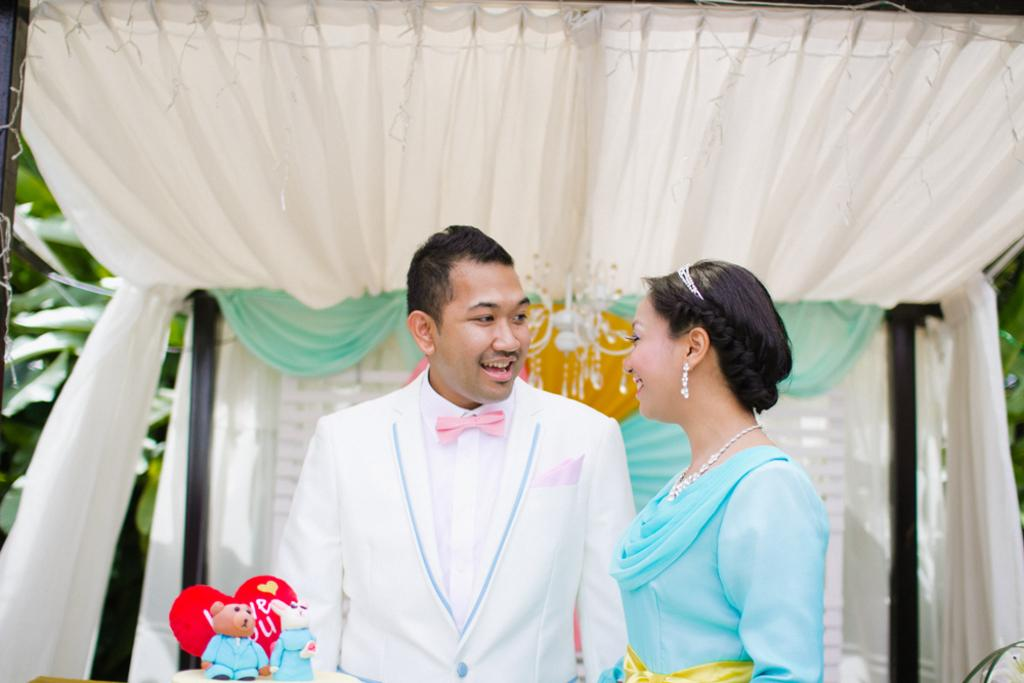How many people are in the image? There are two people standing in the image. What is the facial expression of the people in the image? The people are smiling. What type of objects can be seen in the image besides the people? Toys, curtains, and decorative items are visible in the image. What can be seen in the background of the image? Leaves are visible in the background of the image. How many geese are present in the image? There are no geese present in the image. What type of mineral can be seen in the image? There is no mineral visible in the image. 